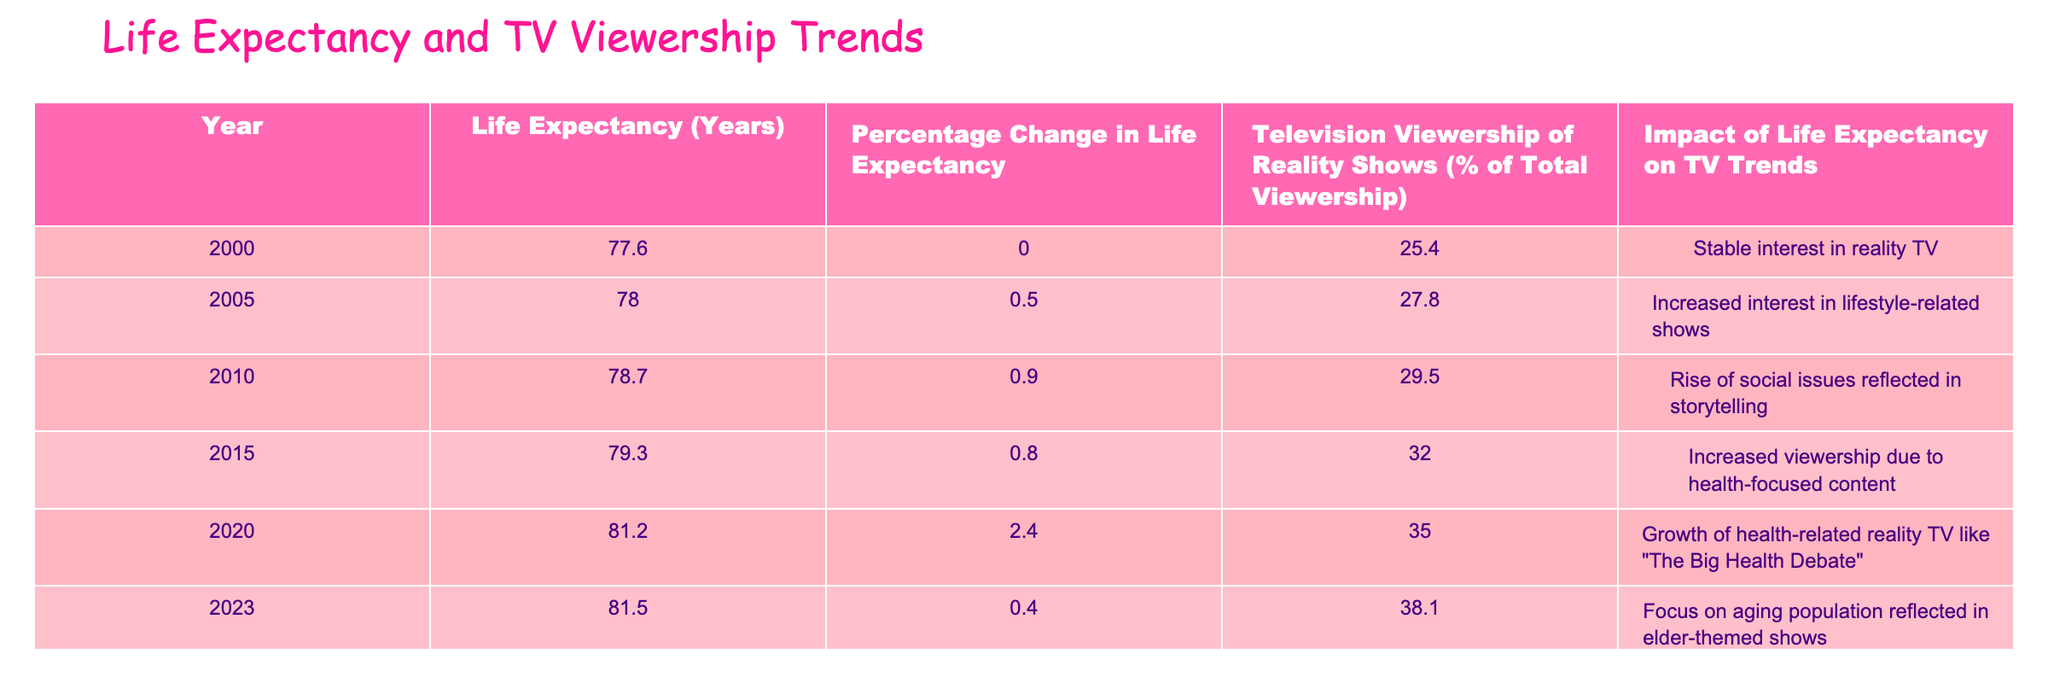What was the life expectancy in the year 2005? Referring to the table, the life expectancy for the year 2005 is directly listed under the "Life Expectancy (Years)" column corresponding to that year. It is given as 78.0 years.
Answer: 78.0 What percentage change in life expectancy was observed from 2010 to 2015? To calculate the percentage change from 2010 to 2015, subtract the life expectancy in 2010 (78.7 years) from that in 2015 (79.3 years), which gives 79.3 - 78.7 = 0.6. Then, divide by 78.7 and multiply by 100 to find the percentage: (0.6 / 78.7) * 100 ≈ 0.76%.
Answer: 0.76% Did the television viewership of reality shows increase every year from 2000 to 2023? By examining the table, the percentage of television viewership of reality shows for each year shows consistent increases from 25.4% in 2000 to 38.1% in 2023. Thus, it is true that viewership increased every year.
Answer: Yes What was the average television viewership of reality shows between 2010 and 2020? The viewership percentages for the years 2010 (29.5%), 2015 (32.0%), and 2020 (35.0%) should be summed and then divided by the number of years to find the average. The sum is 29.5 + 32.0 + 35.0 = 96.5. Dividing that by 3 gives an average of 32.17%.
Answer: 32.17% Which year saw the largest increase in life expectancy in percentage terms? To determine which year had the largest percentage change, we compare the percentage changes given in the table: 2000-2005 = 0.5%, 2005-2010 = 0.9%, 2010-2015 = 0.8%, 2015-2020 = 2.4%, and 2020-2023 = 0.4%. The largest increase is 2.4% from 2015 to 2020.
Answer: 2015 to 2020 How did the impact of life expectancy on TV trends change from 2000 to 2023? By analyzing the "Impact of Life Expectancy on TV Trends" column, we can see that there was a shift from "Stable interest in reality TV" in 2000 to a "Focus on aging population reflected in elder-themed shows" by 2023, indicating that as life expectancy increased, the content became more focused on health and aging issues.
Answer: Shift in focus towards health and aging themes What was the life expectancy in 2023 compared to that in 2000, and how did it affect TV viewership? The life expectancy in 2023 was 81.5 years compared to 77.6 years in 2000, showing an increase of 3.9 years. At the same time, TV viewership of reality shows increased from 25.4% in 2000 to 38.1% in 2023, demonstrating a positive correlation between life expectancy and viewership trends.
Answer: Increased by 3.9 years; viewership increased significantly What is the percentage increase in television viewership of reality shows from 2000 to 2010? To find the percentage increase, we subtract the viewership in 2000 (25.4%) from that in 2010 (29.5%), which gives us 29.5 - 25.4 = 4.1%. To find the percentage, we divide by the original figure (25.4%) and multiply by 100: (4.1 / 25.4) * 100 ≈ 16.14%.
Answer: 16.14% 